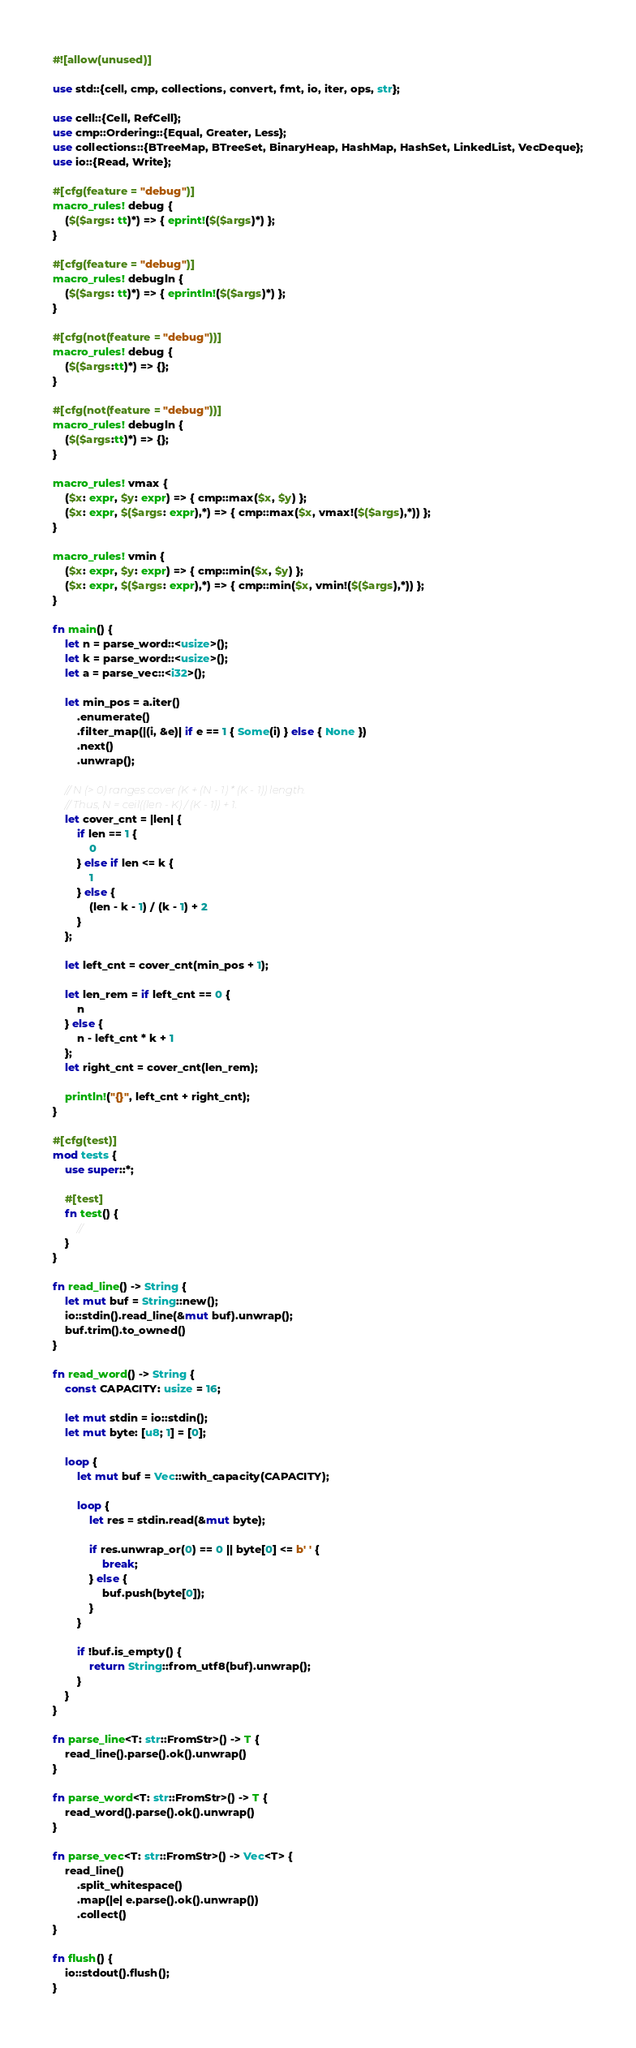<code> <loc_0><loc_0><loc_500><loc_500><_Rust_>#![allow(unused)]

use std::{cell, cmp, collections, convert, fmt, io, iter, ops, str};

use cell::{Cell, RefCell};
use cmp::Ordering::{Equal, Greater, Less};
use collections::{BTreeMap, BTreeSet, BinaryHeap, HashMap, HashSet, LinkedList, VecDeque};
use io::{Read, Write};

#[cfg(feature = "debug")]
macro_rules! debug {
    ($($args: tt)*) => { eprint!($($args)*) };
}

#[cfg(feature = "debug")]
macro_rules! debugln {
    ($($args: tt)*) => { eprintln!($($args)*) };
}

#[cfg(not(feature = "debug"))]
macro_rules! debug {
    ($($args:tt)*) => {};
}

#[cfg(not(feature = "debug"))]
macro_rules! debugln {
    ($($args:tt)*) => {};
}

macro_rules! vmax {
    ($x: expr, $y: expr) => { cmp::max($x, $y) };
    ($x: expr, $($args: expr),*) => { cmp::max($x, vmax!($($args),*)) };
}

macro_rules! vmin {
    ($x: expr, $y: expr) => { cmp::min($x, $y) };
    ($x: expr, $($args: expr),*) => { cmp::min($x, vmin!($($args),*)) };
}

fn main() {
    let n = parse_word::<usize>();
    let k = parse_word::<usize>();
    let a = parse_vec::<i32>();

    let min_pos = a.iter()
        .enumerate()
        .filter_map(|(i, &e)| if e == 1 { Some(i) } else { None })
        .next()
        .unwrap();

    // N (> 0) ranges cover (K + (N - 1) * (K - 1)) length.
    // Thus, N = ceil((len - K) / (K - 1)) + 1.
    let cover_cnt = |len| {
        if len == 1 {
            0
        } else if len <= k {
            1
        } else {
            (len - k - 1) / (k - 1) + 2
        }
    };

    let left_cnt = cover_cnt(min_pos + 1);

    let len_rem = if left_cnt == 0 {
        n
    } else {
        n - left_cnt * k + 1
    };
    let right_cnt = cover_cnt(len_rem);

    println!("{}", left_cnt + right_cnt);
}

#[cfg(test)]
mod tests {
    use super::*;

    #[test]
    fn test() {
        //
    }
}

fn read_line() -> String {
    let mut buf = String::new();
    io::stdin().read_line(&mut buf).unwrap();
    buf.trim().to_owned()
}

fn read_word() -> String {
    const CAPACITY: usize = 16;

    let mut stdin = io::stdin();
    let mut byte: [u8; 1] = [0];

    loop {
        let mut buf = Vec::with_capacity(CAPACITY);

        loop {
            let res = stdin.read(&mut byte);

            if res.unwrap_or(0) == 0 || byte[0] <= b' ' {
                break;
            } else {
                buf.push(byte[0]);
            }
        }

        if !buf.is_empty() {
            return String::from_utf8(buf).unwrap();
        }
    }
}

fn parse_line<T: str::FromStr>() -> T {
    read_line().parse().ok().unwrap()
}

fn parse_word<T: str::FromStr>() -> T {
    read_word().parse().ok().unwrap()
}

fn parse_vec<T: str::FromStr>() -> Vec<T> {
    read_line()
        .split_whitespace()
        .map(|e| e.parse().ok().unwrap())
        .collect()
}

fn flush() {
    io::stdout().flush();
}
</code> 